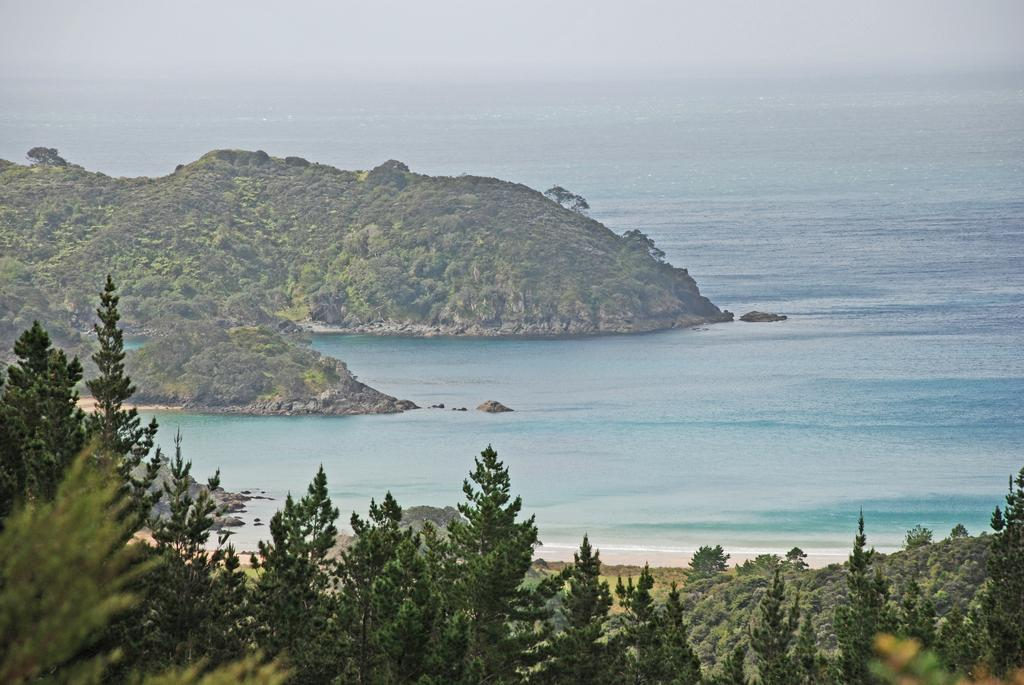What type of landscape can be seen in the image? There are hills in the image. What other natural elements are present in the image? There are trees and water visible in the image. What part of the natural environment is visible in the image? The sky is visible in the image. What type of glove is being used to swim in the water in the image? There is no glove or swimming activity present in the image; it features hills, trees, water, and the sky. 